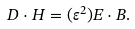<formula> <loc_0><loc_0><loc_500><loc_500>D \cdot H = ( \varepsilon ^ { 2 } ) E \cdot B .</formula> 